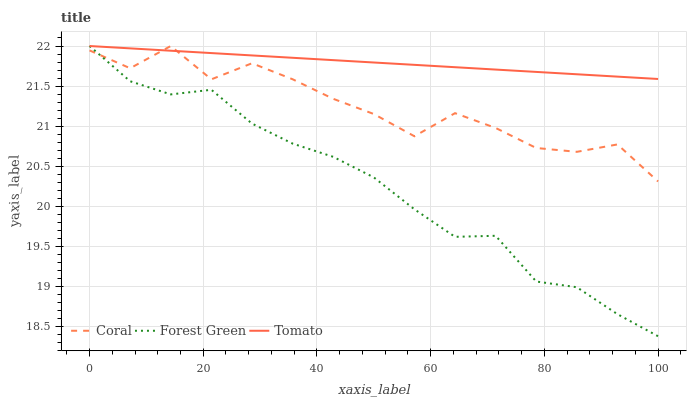Does Coral have the minimum area under the curve?
Answer yes or no. No. Does Coral have the maximum area under the curve?
Answer yes or no. No. Is Forest Green the smoothest?
Answer yes or no. No. Is Forest Green the roughest?
Answer yes or no. No. Does Coral have the lowest value?
Answer yes or no. No. 